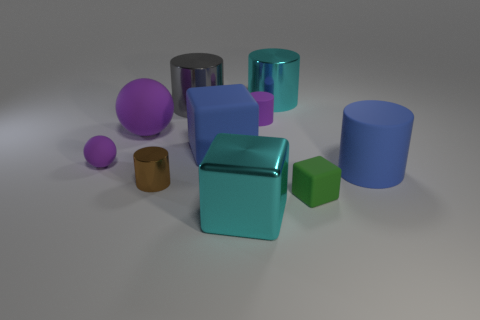Subtract all cyan cylinders. How many cylinders are left? 4 Subtract all small brown cylinders. How many cylinders are left? 4 Subtract all red cylinders. Subtract all purple cubes. How many cylinders are left? 5 Subtract all cubes. How many objects are left? 7 Add 2 purple objects. How many purple objects exist? 5 Subtract 1 cyan cylinders. How many objects are left? 9 Subtract all small metallic balls. Subtract all purple objects. How many objects are left? 7 Add 7 blue rubber things. How many blue rubber things are left? 9 